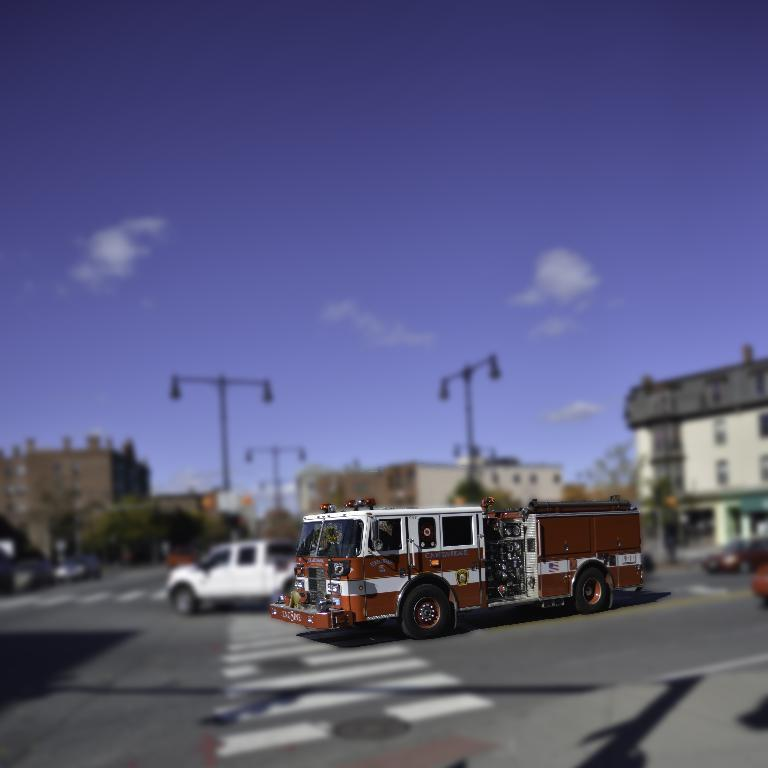What is the main subject of the image? There is a vehicle on the road in the image. How would you describe the background of the image? The background of the image has a blurred view. What can be seen in the background besides the blurred view? There are vehicles, poles, trees, and buildings visible in the background. What part of the natural environment is visible in the image? The sky is visible in the image. Can you see a carriage being pulled by a hen in the image? No, there is no carriage or hen present in the image. 